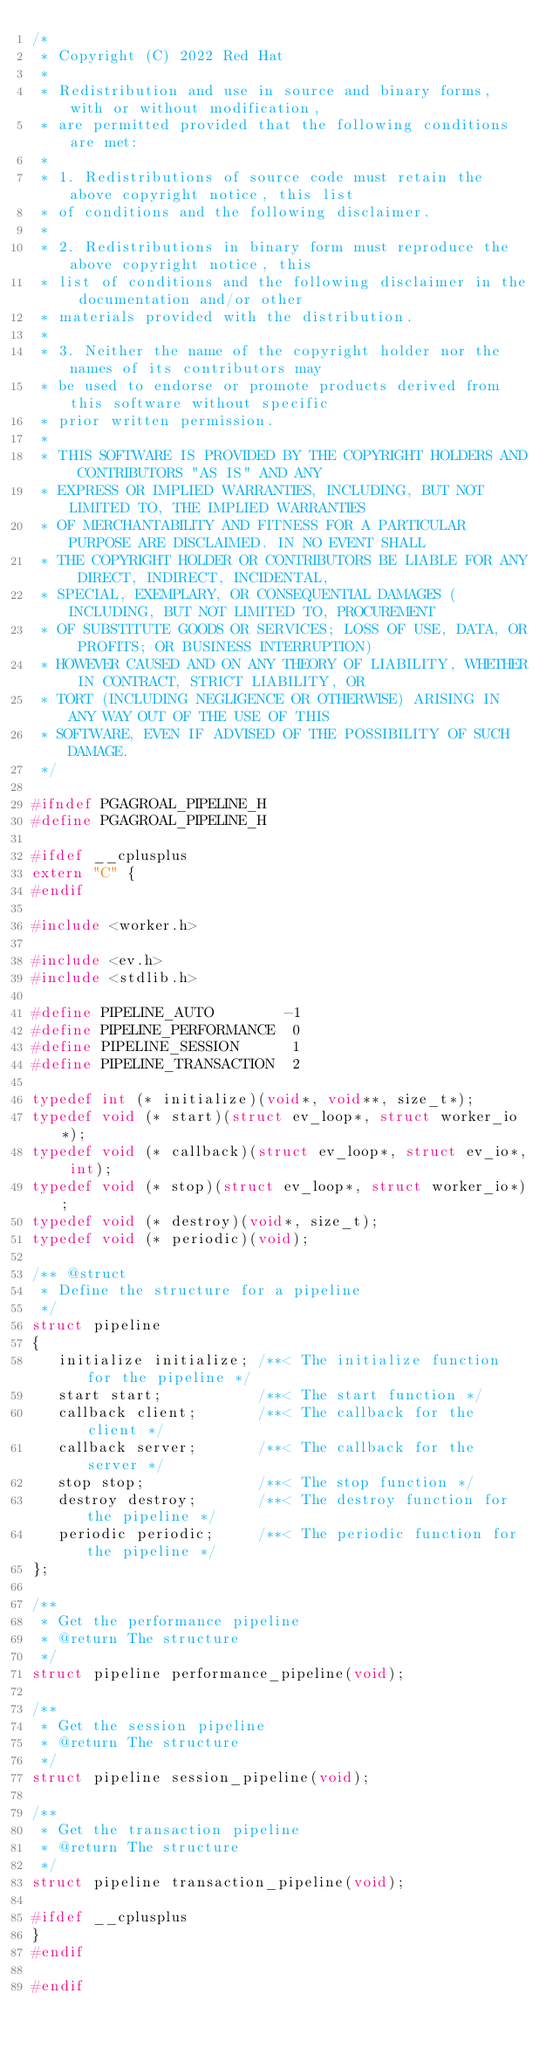<code> <loc_0><loc_0><loc_500><loc_500><_C_>/*
 * Copyright (C) 2022 Red Hat
 *
 * Redistribution and use in source and binary forms, with or without modification,
 * are permitted provided that the following conditions are met:
 *
 * 1. Redistributions of source code must retain the above copyright notice, this list
 * of conditions and the following disclaimer.
 *
 * 2. Redistributions in binary form must reproduce the above copyright notice, this
 * list of conditions and the following disclaimer in the documentation and/or other
 * materials provided with the distribution.
 *
 * 3. Neither the name of the copyright holder nor the names of its contributors may
 * be used to endorse or promote products derived from this software without specific
 * prior written permission.
 *
 * THIS SOFTWARE IS PROVIDED BY THE COPYRIGHT HOLDERS AND CONTRIBUTORS "AS IS" AND ANY
 * EXPRESS OR IMPLIED WARRANTIES, INCLUDING, BUT NOT LIMITED TO, THE IMPLIED WARRANTIES
 * OF MERCHANTABILITY AND FITNESS FOR A PARTICULAR PURPOSE ARE DISCLAIMED. IN NO EVENT SHALL
 * THE COPYRIGHT HOLDER OR CONTRIBUTORS BE LIABLE FOR ANY DIRECT, INDIRECT, INCIDENTAL,
 * SPECIAL, EXEMPLARY, OR CONSEQUENTIAL DAMAGES (INCLUDING, BUT NOT LIMITED TO, PROCUREMENT
 * OF SUBSTITUTE GOODS OR SERVICES; LOSS OF USE, DATA, OR PROFITS; OR BUSINESS INTERRUPTION)
 * HOWEVER CAUSED AND ON ANY THEORY OF LIABILITY, WHETHER IN CONTRACT, STRICT LIABILITY, OR
 * TORT (INCLUDING NEGLIGENCE OR OTHERWISE) ARISING IN ANY WAY OUT OF THE USE OF THIS
 * SOFTWARE, EVEN IF ADVISED OF THE POSSIBILITY OF SUCH DAMAGE.
 */

#ifndef PGAGROAL_PIPELINE_H
#define PGAGROAL_PIPELINE_H

#ifdef __cplusplus
extern "C" {
#endif

#include <worker.h>

#include <ev.h>
#include <stdlib.h>

#define PIPELINE_AUTO        -1
#define PIPELINE_PERFORMANCE  0
#define PIPELINE_SESSION      1
#define PIPELINE_TRANSACTION  2

typedef int (* initialize)(void*, void**, size_t*);
typedef void (* start)(struct ev_loop*, struct worker_io*);
typedef void (* callback)(struct ev_loop*, struct ev_io*, int);
typedef void (* stop)(struct ev_loop*, struct worker_io*);
typedef void (* destroy)(void*, size_t);
typedef void (* periodic)(void);

/** @struct
 * Define the structure for a pipeline
 */
struct pipeline
{
   initialize initialize; /**< The initialize function for the pipeline */
   start start;           /**< The start function */
   callback client;       /**< The callback for the client */
   callback server;       /**< The callback for the server */
   stop stop;             /**< The stop function */
   destroy destroy;       /**< The destroy function for the pipeline */
   periodic periodic;     /**< The periodic function for the pipeline */
};

/**
 * Get the performance pipeline
 * @return The structure
 */
struct pipeline performance_pipeline(void);

/**
 * Get the session pipeline
 * @return The structure
 */
struct pipeline session_pipeline(void);

/**
 * Get the transaction pipeline
 * @return The structure
 */
struct pipeline transaction_pipeline(void);

#ifdef __cplusplus
}
#endif

#endif
</code> 